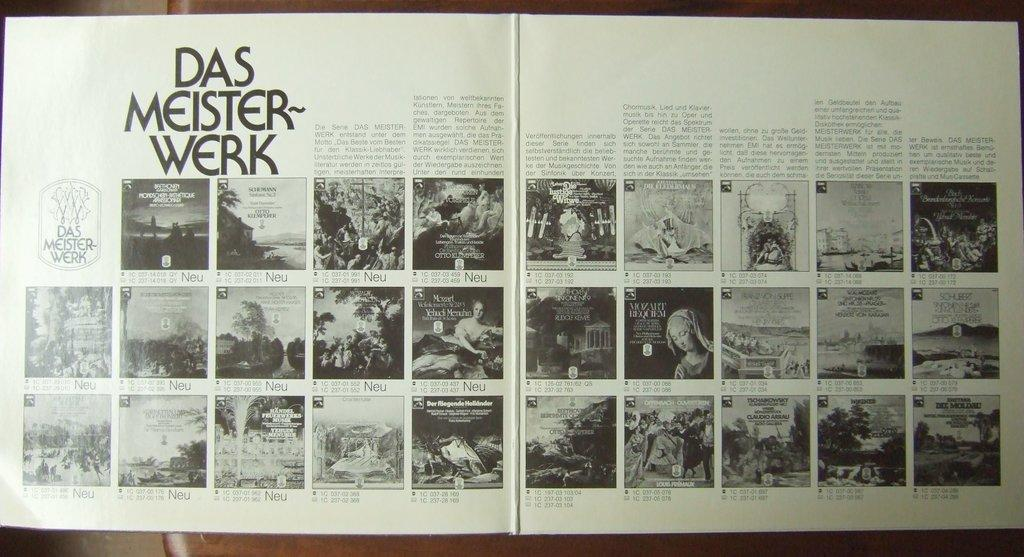<image>
Offer a succinct explanation of the picture presented. Open book showing some photos and the words "Das Meister Werk" on top. 